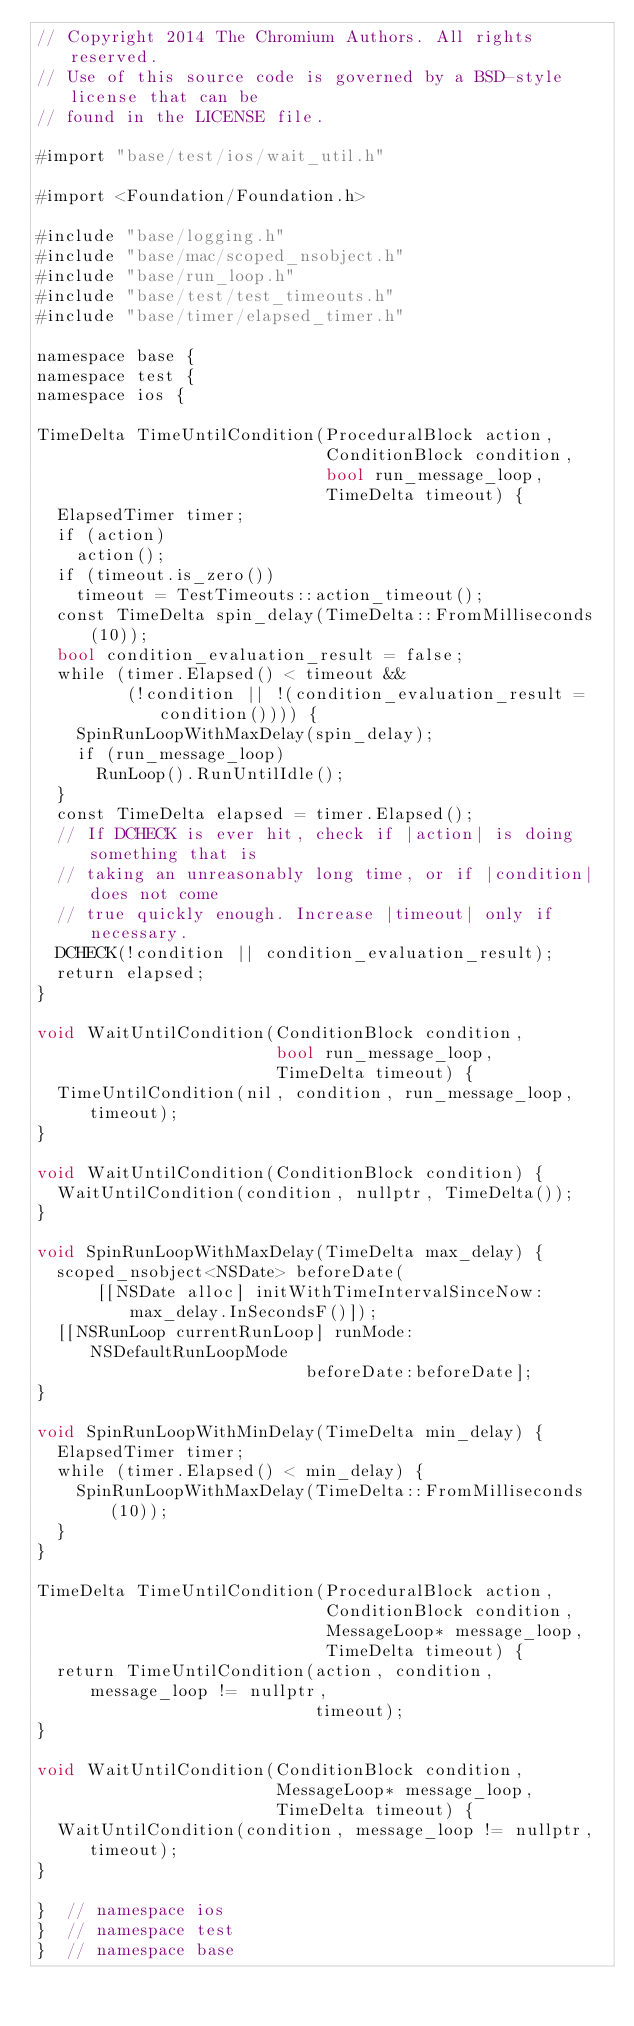<code> <loc_0><loc_0><loc_500><loc_500><_ObjectiveC_>// Copyright 2014 The Chromium Authors. All rights reserved.
// Use of this source code is governed by a BSD-style license that can be
// found in the LICENSE file.

#import "base/test/ios/wait_util.h"

#import <Foundation/Foundation.h>

#include "base/logging.h"
#include "base/mac/scoped_nsobject.h"
#include "base/run_loop.h"
#include "base/test/test_timeouts.h"
#include "base/timer/elapsed_timer.h"

namespace base {
namespace test {
namespace ios {

TimeDelta TimeUntilCondition(ProceduralBlock action,
                             ConditionBlock condition,
                             bool run_message_loop,
                             TimeDelta timeout) {
  ElapsedTimer timer;
  if (action)
    action();
  if (timeout.is_zero())
    timeout = TestTimeouts::action_timeout();
  const TimeDelta spin_delay(TimeDelta::FromMilliseconds(10));
  bool condition_evaluation_result = false;
  while (timer.Elapsed() < timeout &&
         (!condition || !(condition_evaluation_result = condition()))) {
    SpinRunLoopWithMaxDelay(spin_delay);
    if (run_message_loop)
      RunLoop().RunUntilIdle();
  }
  const TimeDelta elapsed = timer.Elapsed();
  // If DCHECK is ever hit, check if |action| is doing something that is
  // taking an unreasonably long time, or if |condition| does not come
  // true quickly enough. Increase |timeout| only if necessary.
  DCHECK(!condition || condition_evaluation_result);
  return elapsed;
}

void WaitUntilCondition(ConditionBlock condition,
                        bool run_message_loop,
                        TimeDelta timeout) {
  TimeUntilCondition(nil, condition, run_message_loop, timeout);
}

void WaitUntilCondition(ConditionBlock condition) {
  WaitUntilCondition(condition, nullptr, TimeDelta());
}

void SpinRunLoopWithMaxDelay(TimeDelta max_delay) {
  scoped_nsobject<NSDate> beforeDate(
      [[NSDate alloc] initWithTimeIntervalSinceNow:max_delay.InSecondsF()]);
  [[NSRunLoop currentRunLoop] runMode:NSDefaultRunLoopMode
                           beforeDate:beforeDate];
}

void SpinRunLoopWithMinDelay(TimeDelta min_delay) {
  ElapsedTimer timer;
  while (timer.Elapsed() < min_delay) {
    SpinRunLoopWithMaxDelay(TimeDelta::FromMilliseconds(10));
  }
}

TimeDelta TimeUntilCondition(ProceduralBlock action,
                             ConditionBlock condition,
                             MessageLoop* message_loop,
                             TimeDelta timeout) {
  return TimeUntilCondition(action, condition, message_loop != nullptr,
                            timeout);
}

void WaitUntilCondition(ConditionBlock condition,
                        MessageLoop* message_loop,
                        TimeDelta timeout) {
  WaitUntilCondition(condition, message_loop != nullptr, timeout);
}

}  // namespace ios
}  // namespace test
}  // namespace base
</code> 